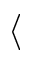<formula> <loc_0><loc_0><loc_500><loc_500>\langle</formula> 